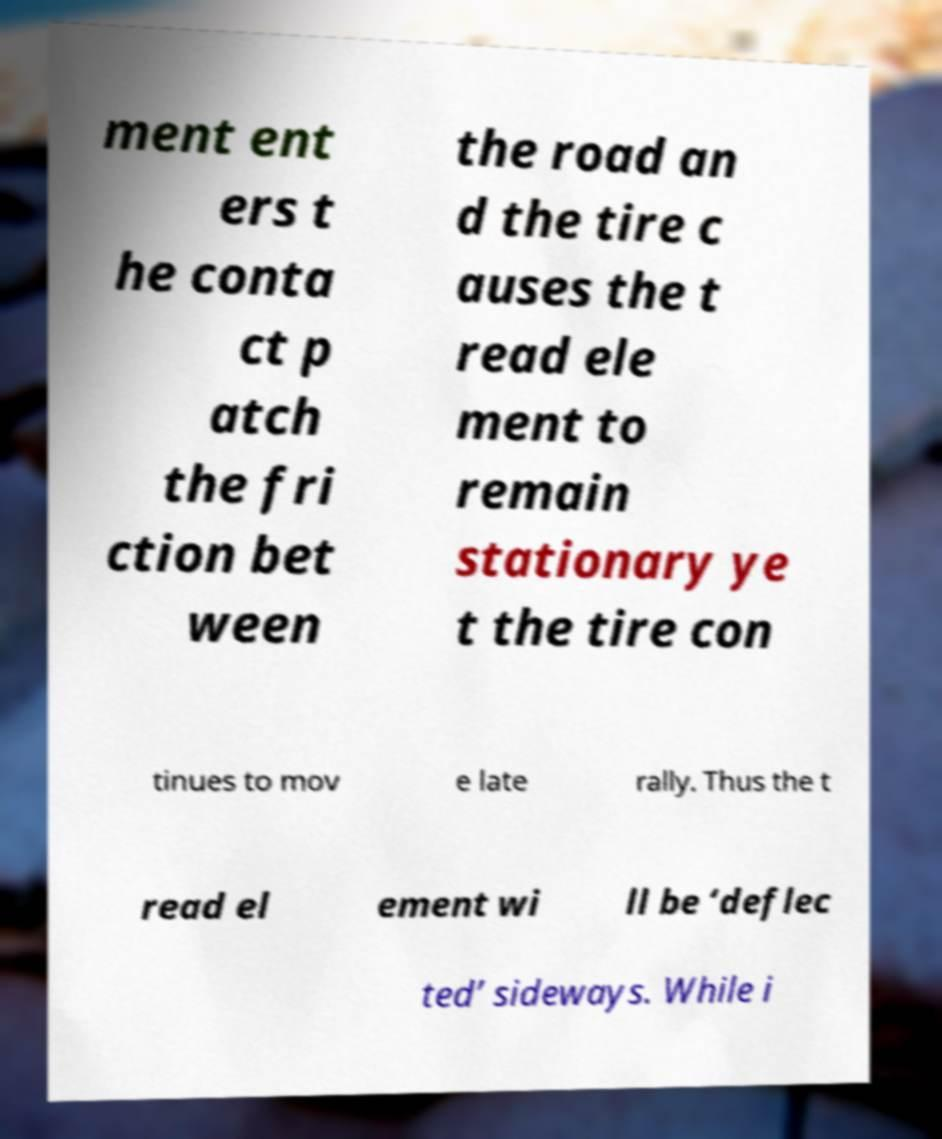Please read and relay the text visible in this image. What does it say? ment ent ers t he conta ct p atch the fri ction bet ween the road an d the tire c auses the t read ele ment to remain stationary ye t the tire con tinues to mov e late rally. Thus the t read el ement wi ll be ‘deflec ted’ sideways. While i 